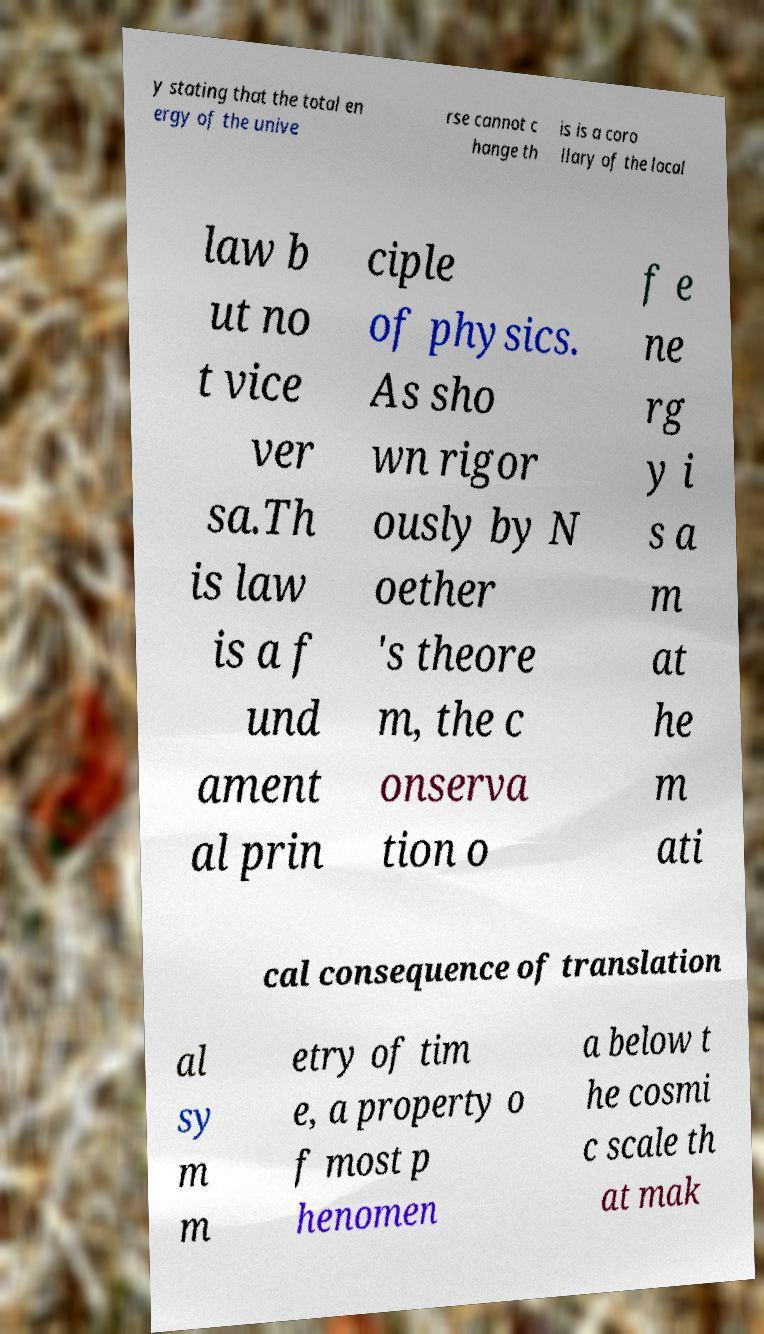Could you assist in decoding the text presented in this image and type it out clearly? y stating that the total en ergy of the unive rse cannot c hange th is is a coro llary of the local law b ut no t vice ver sa.Th is law is a f und ament al prin ciple of physics. As sho wn rigor ously by N oether 's theore m, the c onserva tion o f e ne rg y i s a m at he m ati cal consequence of translation al sy m m etry of tim e, a property o f most p henomen a below t he cosmi c scale th at mak 